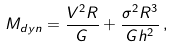Convert formula to latex. <formula><loc_0><loc_0><loc_500><loc_500>M _ { d y n } = \frac { V ^ { 2 } R } { G } + \frac { \sigma ^ { 2 } R ^ { 3 } } { G h ^ { 2 } } \, ,</formula> 